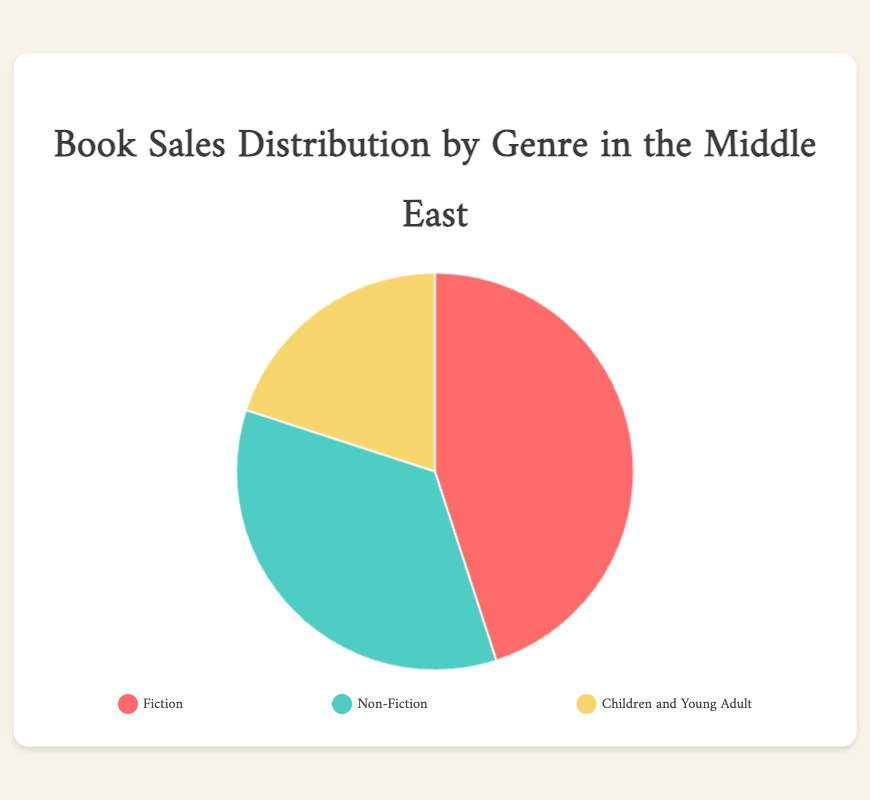What percentage of book sales is attributed to Non-Fiction? Refer to the visual pie chart and locate the segment labeled "Non-Fiction". The chart shows the percentage as 35%.
Answer: 35% Which genre has the highest percentage of book sales? Identify the largest segment in the pie chart visually. The "Fiction" segment is the largest, showing 45%.
Answer: Fiction How much more book sales percentage does Fiction have compared to Children and Young Adult? Locate the percentages for Fiction (45%) and Children and Young Adult (20%). Subtract to find the difference: 45% - 20% = 25%.
Answer: 25% What is the combined book sales percentage for Fiction and Non-Fiction? Add the percentages of Fiction (45%) and Non-Fiction (35%). The total is 45% + 35% = 80%.
Answer: 80% Which genre has the smallest share of book sales? Identify the smallest segment in the pie chart. The "Children and Young Adult" segment is the smallest, showing 20%.
Answer: Children and Young Adult What is the average book sales percentage among all three genres? Add the percentages of all three genres and divide by the number of genres: (45% + 35% + 20%) / 3 = 100% / 3 ≈ 33.33%.
Answer: 33.33% Does Non-Fiction represent more than one-third of the book sales percentage? One-third of 100% is approximately 33.33%. Non-Fiction has 35%, which is more than 33.33%.
Answer: Yes What color represents the segment for Children and Young Adult? Look at the chart legend. The "Children and Young Adult" segment is represented by the yellow color.
Answer: Yellow If the total book sales is 1,000,000, how many units are sold for Non-Fiction? Non-Fiction represents 35% of total sales. Calculate 35% of 1,000,000: 1,000,000 * 0.35 = 350,000 units.
Answer: 350,000 units What is the difference in book sales percentage between the top two genres? The top two genres are Fiction (45%) and Non-Fiction (35%). Subtract to find the difference: 45% - 35% = 10%.
Answer: 10% 